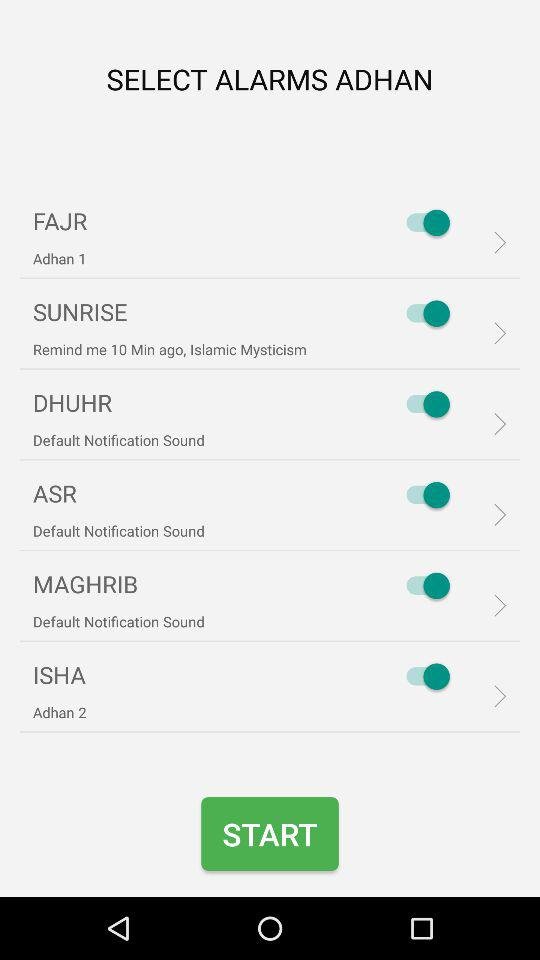What is the status of the "FAJR"? The status of the "FAJR" is "on". 